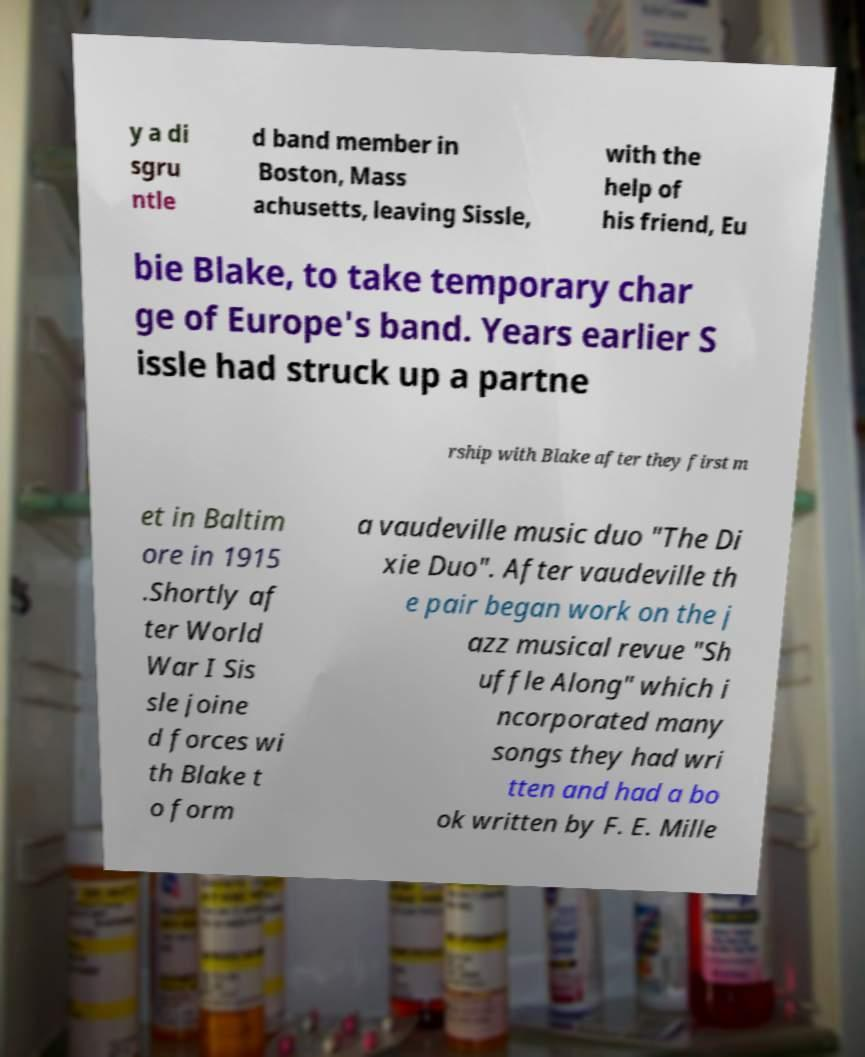Can you read and provide the text displayed in the image?This photo seems to have some interesting text. Can you extract and type it out for me? y a di sgru ntle d band member in Boston, Mass achusetts, leaving Sissle, with the help of his friend, Eu bie Blake, to take temporary char ge of Europe's band. Years earlier S issle had struck up a partne rship with Blake after they first m et in Baltim ore in 1915 .Shortly af ter World War I Sis sle joine d forces wi th Blake t o form a vaudeville music duo "The Di xie Duo". After vaudeville th e pair began work on the j azz musical revue "Sh uffle Along" which i ncorporated many songs they had wri tten and had a bo ok written by F. E. Mille 